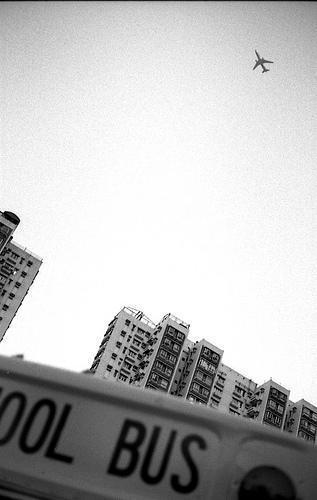How many airplanes are there?
Give a very brief answer. 1. 